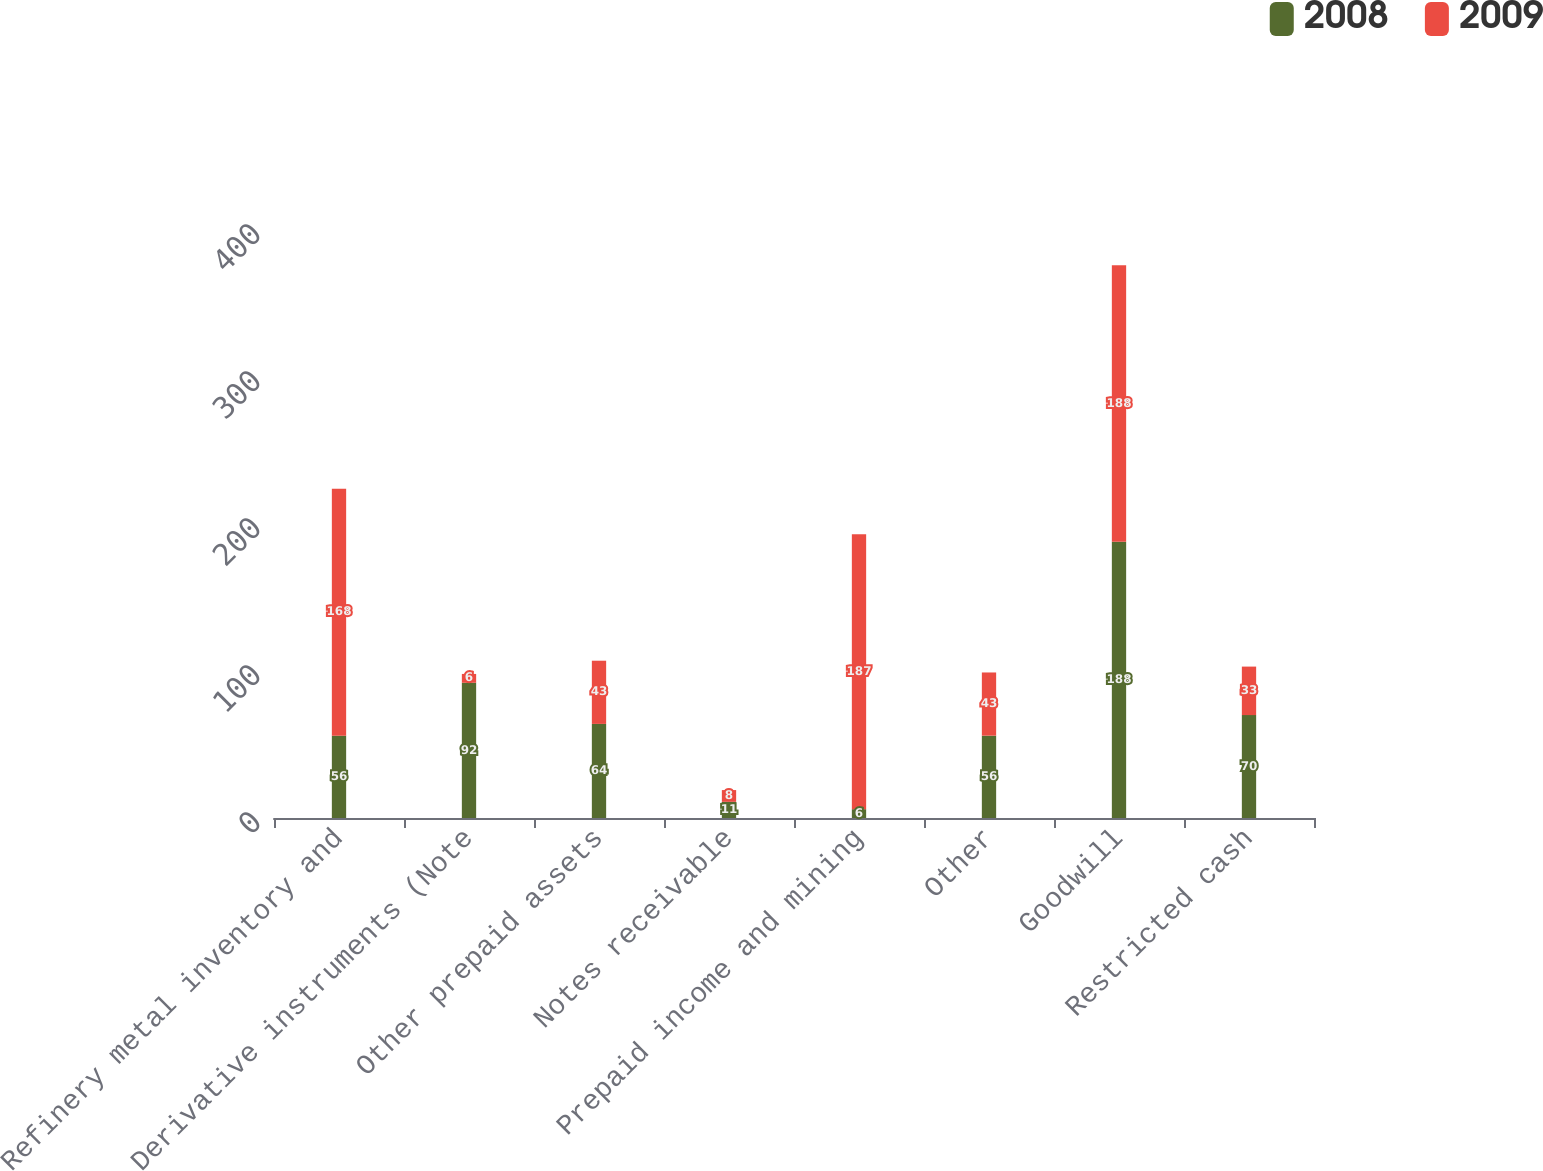Convert chart. <chart><loc_0><loc_0><loc_500><loc_500><stacked_bar_chart><ecel><fcel>Refinery metal inventory and<fcel>Derivative instruments (Note<fcel>Other prepaid assets<fcel>Notes receivable<fcel>Prepaid income and mining<fcel>Other<fcel>Goodwill<fcel>Restricted cash<nl><fcel>2008<fcel>56<fcel>92<fcel>64<fcel>11<fcel>6<fcel>56<fcel>188<fcel>70<nl><fcel>2009<fcel>168<fcel>6<fcel>43<fcel>8<fcel>187<fcel>43<fcel>188<fcel>33<nl></chart> 